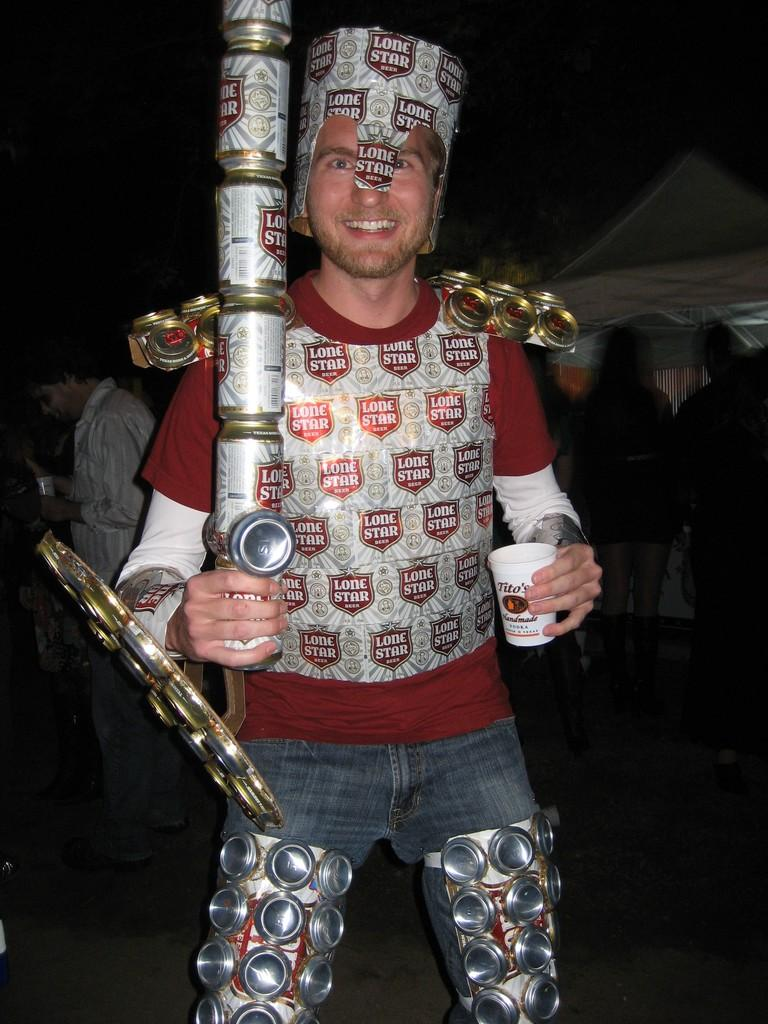What is the main subject of the image? There is a man in the image. What is the man doing in the image? The man is standing and holding cans in one hand and a cup in the other hand. What is the man wearing on his head? The man is wearing a cap. How is the man's facial expression in the image? The man has a smile on his face. Are there any other people in the image? Yes, there are people standing in the image. What type of bag is the man carrying in the image? There is no bag visible in the image; the man is holding cans and a cup. How does the man divide the cans among the people in the image? The image does not show the man dividing the cans among people, as it only depicts him holding them in one hand. 